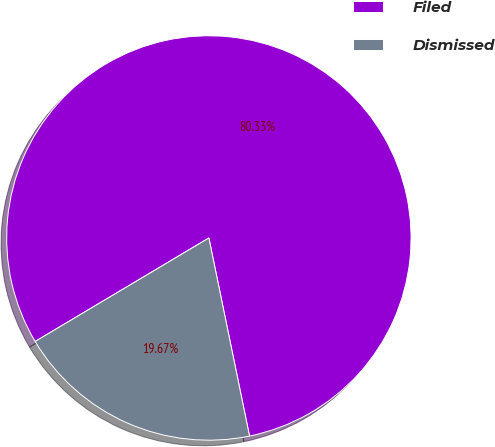<chart> <loc_0><loc_0><loc_500><loc_500><pie_chart><fcel>Filed<fcel>Dismissed<nl><fcel>80.33%<fcel>19.67%<nl></chart> 